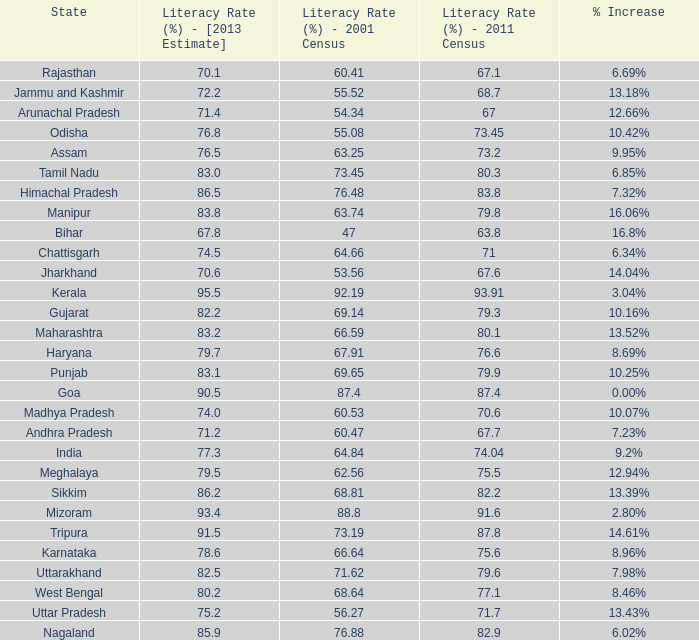What was the literacy rate published in the 2001 census for the state that saw a 12.66% increase? 54.34. 